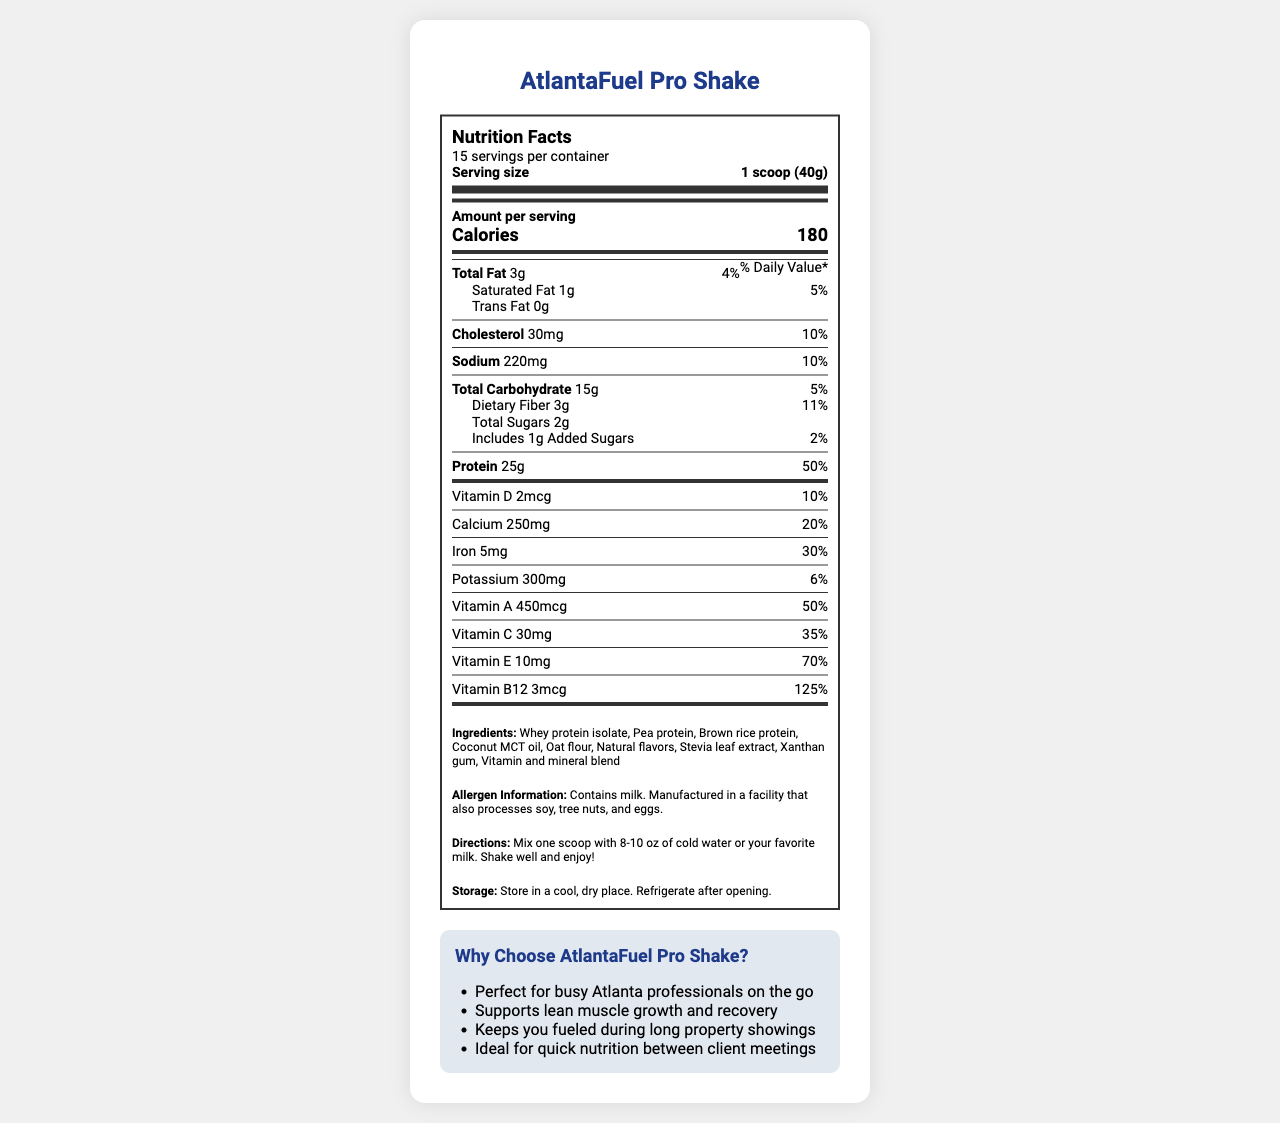What is the serving size for AtlantaFuel Pro Shake? The serving size is clearly listed at the top of the Nutrition Facts label.
Answer: 1 scoop (40g) How many calories are in one serving? The Nutrition Facts label indicates there are 180 calories per serving.
Answer: 180 What is the total fat content per serving? The total fat content per serving is mentioned in the Nutrition Facts label as 3 grams.
Answer: 3g Is there any trans fat in the shake? The label specifies that the shake contains 0 grams of trans fat.
Answer: No How much protein does one serving provide? The Nutrition Facts shows that one serving contains 25 grams of protein.
Answer: 25g What is the daily value percentage of Iron in one serving? The daily value percentage for Iron is listed as 30% on the label.
Answer: 30% Which vitamin has the highest daily value percentage per serving? A. Vitamin D B. Vitamin C C. Vitamin E D. Vitamin B12 Vitamin B12 has a daily value of 125%, which is the highest among the listed vitamins.
Answer: D. Vitamin B12 What are the ingredients that start with the letter "P"? A. Pea protein, Potassium B. Pea protein, Pea extract C. Pea protein, Pea flour D. None of the above The ingredients listed include Pea protein, and Potassium is included in the nutrients.
Answer: A. Pea protein, Potassium Does the shake contain any allergens? The allergen information clearly states the shake contains milk and is manufactured in a facility that processes soy, tree nuts, and eggs.
Answer: Yes Summarize the key benefits of the AtlantaFuel Pro Shake. The benefits section and the marketing claims emphasize the shake's suitability for busy professionals, its support for muscle growth, and the convenience it offers in terms of nutrition.
Answer: The AtlantaFuel Pro Shake is marketed as an ideal high-protein meal replacement for busy professionals, supporting lean muscle growth, providing quick nutrition between client meetings, and keeping users fueled during long property showings. It contains significant amounts of vitamins and minerals, which contribute to its nutritional value. Are the instructions for preparing the shake clear? The directions for use are clearly mentioned: mix one scoop with 8-10 oz of cold water or milk, shake well, and enjoy.
Answer: Yes Can you determine the retail price of the AtlantaFuel Pro Shake from the document? The document does not provide any details regarding the retail price.
Answer: Not enough information 